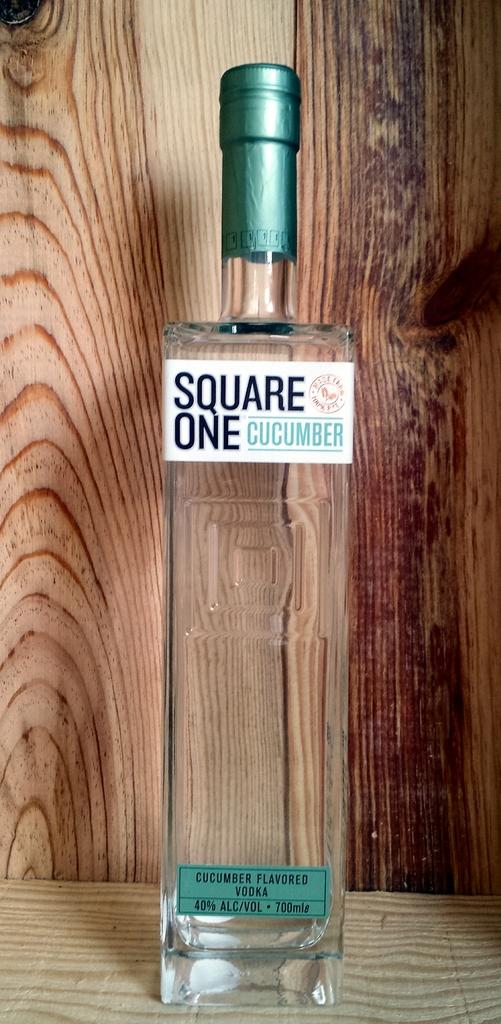Is this cucumber flavored?
Offer a terse response. Yes. How much is this?
Give a very brief answer. Unanswerable. 